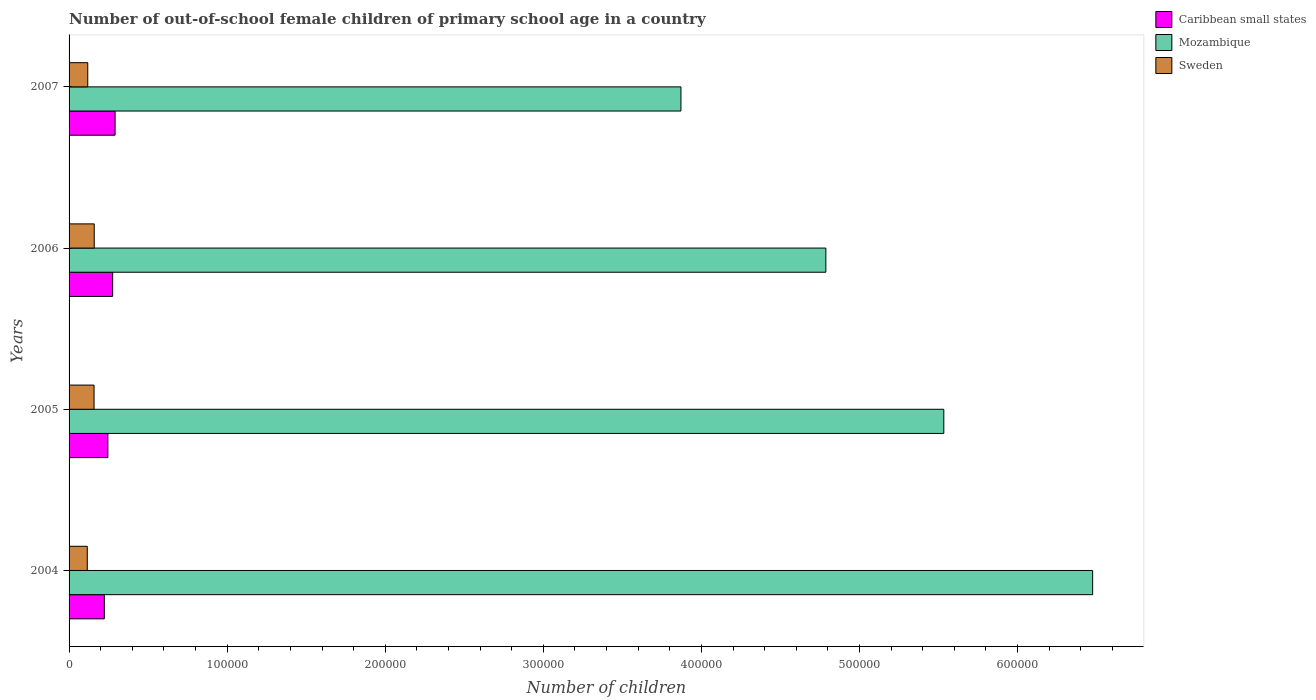How many different coloured bars are there?
Provide a succinct answer. 3. Are the number of bars per tick equal to the number of legend labels?
Make the answer very short. Yes. How many bars are there on the 3rd tick from the bottom?
Keep it short and to the point. 3. What is the label of the 4th group of bars from the top?
Ensure brevity in your answer.  2004. What is the number of out-of-school female children in Caribbean small states in 2007?
Your answer should be compact. 2.91e+04. Across all years, what is the maximum number of out-of-school female children in Mozambique?
Provide a succinct answer. 6.48e+05. Across all years, what is the minimum number of out-of-school female children in Mozambique?
Your response must be concise. 3.87e+05. In which year was the number of out-of-school female children in Sweden minimum?
Offer a very short reply. 2004. What is the total number of out-of-school female children in Sweden in the graph?
Provide a succinct answer. 5.51e+04. What is the difference between the number of out-of-school female children in Caribbean small states in 2004 and that in 2007?
Give a very brief answer. -6797. What is the difference between the number of out-of-school female children in Sweden in 2006 and the number of out-of-school female children in Caribbean small states in 2007?
Offer a terse response. -1.32e+04. What is the average number of out-of-school female children in Caribbean small states per year?
Provide a succinct answer. 2.59e+04. In the year 2007, what is the difference between the number of out-of-school female children in Mozambique and number of out-of-school female children in Sweden?
Offer a terse response. 3.75e+05. In how many years, is the number of out-of-school female children in Mozambique greater than 520000 ?
Ensure brevity in your answer.  2. What is the ratio of the number of out-of-school female children in Mozambique in 2004 to that in 2005?
Provide a short and direct response. 1.17. Is the number of out-of-school female children in Sweden in 2005 less than that in 2007?
Offer a terse response. No. What is the difference between the highest and the second highest number of out-of-school female children in Sweden?
Your answer should be compact. 113. What is the difference between the highest and the lowest number of out-of-school female children in Sweden?
Give a very brief answer. 4399. In how many years, is the number of out-of-school female children in Caribbean small states greater than the average number of out-of-school female children in Caribbean small states taken over all years?
Make the answer very short. 2. Is the sum of the number of out-of-school female children in Caribbean small states in 2004 and 2007 greater than the maximum number of out-of-school female children in Mozambique across all years?
Offer a terse response. No. What does the 3rd bar from the bottom in 2006 represents?
Provide a succinct answer. Sweden. Is it the case that in every year, the sum of the number of out-of-school female children in Mozambique and number of out-of-school female children in Caribbean small states is greater than the number of out-of-school female children in Sweden?
Make the answer very short. Yes. How many bars are there?
Keep it short and to the point. 12. Does the graph contain grids?
Your answer should be very brief. No. Where does the legend appear in the graph?
Give a very brief answer. Top right. How many legend labels are there?
Ensure brevity in your answer.  3. What is the title of the graph?
Make the answer very short. Number of out-of-school female children of primary school age in a country. What is the label or title of the X-axis?
Keep it short and to the point. Number of children. What is the label or title of the Y-axis?
Give a very brief answer. Years. What is the Number of children of Caribbean small states in 2004?
Provide a succinct answer. 2.23e+04. What is the Number of children in Mozambique in 2004?
Your answer should be compact. 6.48e+05. What is the Number of children in Sweden in 2004?
Offer a very short reply. 1.15e+04. What is the Number of children in Caribbean small states in 2005?
Keep it short and to the point. 2.46e+04. What is the Number of children in Mozambique in 2005?
Offer a very short reply. 5.53e+05. What is the Number of children in Sweden in 2005?
Offer a very short reply. 1.58e+04. What is the Number of children in Caribbean small states in 2006?
Provide a succinct answer. 2.76e+04. What is the Number of children in Mozambique in 2006?
Your answer should be compact. 4.79e+05. What is the Number of children of Sweden in 2006?
Make the answer very short. 1.59e+04. What is the Number of children in Caribbean small states in 2007?
Ensure brevity in your answer.  2.91e+04. What is the Number of children in Mozambique in 2007?
Your answer should be very brief. 3.87e+05. What is the Number of children of Sweden in 2007?
Provide a succinct answer. 1.18e+04. Across all years, what is the maximum Number of children in Caribbean small states?
Give a very brief answer. 2.91e+04. Across all years, what is the maximum Number of children in Mozambique?
Your response must be concise. 6.48e+05. Across all years, what is the maximum Number of children in Sweden?
Your answer should be very brief. 1.59e+04. Across all years, what is the minimum Number of children of Caribbean small states?
Make the answer very short. 2.23e+04. Across all years, what is the minimum Number of children in Mozambique?
Provide a succinct answer. 3.87e+05. Across all years, what is the minimum Number of children in Sweden?
Make the answer very short. 1.15e+04. What is the total Number of children of Caribbean small states in the graph?
Your answer should be compact. 1.04e+05. What is the total Number of children in Mozambique in the graph?
Provide a short and direct response. 2.07e+06. What is the total Number of children of Sweden in the graph?
Make the answer very short. 5.51e+04. What is the difference between the Number of children in Caribbean small states in 2004 and that in 2005?
Ensure brevity in your answer.  -2240. What is the difference between the Number of children of Mozambique in 2004 and that in 2005?
Offer a very short reply. 9.42e+04. What is the difference between the Number of children in Sweden in 2004 and that in 2005?
Offer a terse response. -4286. What is the difference between the Number of children of Caribbean small states in 2004 and that in 2006?
Your response must be concise. -5264. What is the difference between the Number of children in Mozambique in 2004 and that in 2006?
Provide a succinct answer. 1.69e+05. What is the difference between the Number of children of Sweden in 2004 and that in 2006?
Give a very brief answer. -4399. What is the difference between the Number of children in Caribbean small states in 2004 and that in 2007?
Provide a short and direct response. -6797. What is the difference between the Number of children in Mozambique in 2004 and that in 2007?
Provide a short and direct response. 2.60e+05. What is the difference between the Number of children of Sweden in 2004 and that in 2007?
Ensure brevity in your answer.  -294. What is the difference between the Number of children in Caribbean small states in 2005 and that in 2006?
Your response must be concise. -3024. What is the difference between the Number of children of Mozambique in 2005 and that in 2006?
Provide a short and direct response. 7.46e+04. What is the difference between the Number of children of Sweden in 2005 and that in 2006?
Ensure brevity in your answer.  -113. What is the difference between the Number of children of Caribbean small states in 2005 and that in 2007?
Provide a short and direct response. -4557. What is the difference between the Number of children in Mozambique in 2005 and that in 2007?
Offer a very short reply. 1.66e+05. What is the difference between the Number of children in Sweden in 2005 and that in 2007?
Offer a very short reply. 3992. What is the difference between the Number of children of Caribbean small states in 2006 and that in 2007?
Provide a succinct answer. -1533. What is the difference between the Number of children in Mozambique in 2006 and that in 2007?
Your answer should be compact. 9.17e+04. What is the difference between the Number of children in Sweden in 2006 and that in 2007?
Provide a succinct answer. 4105. What is the difference between the Number of children in Caribbean small states in 2004 and the Number of children in Mozambique in 2005?
Ensure brevity in your answer.  -5.31e+05. What is the difference between the Number of children in Caribbean small states in 2004 and the Number of children in Sweden in 2005?
Give a very brief answer. 6503. What is the difference between the Number of children of Mozambique in 2004 and the Number of children of Sweden in 2005?
Provide a short and direct response. 6.32e+05. What is the difference between the Number of children of Caribbean small states in 2004 and the Number of children of Mozambique in 2006?
Your response must be concise. -4.56e+05. What is the difference between the Number of children of Caribbean small states in 2004 and the Number of children of Sweden in 2006?
Offer a very short reply. 6390. What is the difference between the Number of children in Mozambique in 2004 and the Number of children in Sweden in 2006?
Offer a terse response. 6.32e+05. What is the difference between the Number of children in Caribbean small states in 2004 and the Number of children in Mozambique in 2007?
Give a very brief answer. -3.65e+05. What is the difference between the Number of children in Caribbean small states in 2004 and the Number of children in Sweden in 2007?
Ensure brevity in your answer.  1.05e+04. What is the difference between the Number of children in Mozambique in 2004 and the Number of children in Sweden in 2007?
Make the answer very short. 6.36e+05. What is the difference between the Number of children of Caribbean small states in 2005 and the Number of children of Mozambique in 2006?
Give a very brief answer. -4.54e+05. What is the difference between the Number of children in Caribbean small states in 2005 and the Number of children in Sweden in 2006?
Offer a terse response. 8630. What is the difference between the Number of children in Mozambique in 2005 and the Number of children in Sweden in 2006?
Provide a succinct answer. 5.37e+05. What is the difference between the Number of children in Caribbean small states in 2005 and the Number of children in Mozambique in 2007?
Provide a succinct answer. -3.63e+05. What is the difference between the Number of children in Caribbean small states in 2005 and the Number of children in Sweden in 2007?
Make the answer very short. 1.27e+04. What is the difference between the Number of children of Mozambique in 2005 and the Number of children of Sweden in 2007?
Provide a short and direct response. 5.42e+05. What is the difference between the Number of children in Caribbean small states in 2006 and the Number of children in Mozambique in 2007?
Give a very brief answer. -3.59e+05. What is the difference between the Number of children of Caribbean small states in 2006 and the Number of children of Sweden in 2007?
Offer a very short reply. 1.58e+04. What is the difference between the Number of children in Mozambique in 2006 and the Number of children in Sweden in 2007?
Give a very brief answer. 4.67e+05. What is the average Number of children of Caribbean small states per year?
Give a very brief answer. 2.59e+04. What is the average Number of children of Mozambique per year?
Provide a succinct answer. 5.17e+05. What is the average Number of children of Sweden per year?
Make the answer very short. 1.38e+04. In the year 2004, what is the difference between the Number of children of Caribbean small states and Number of children of Mozambique?
Make the answer very short. -6.25e+05. In the year 2004, what is the difference between the Number of children in Caribbean small states and Number of children in Sweden?
Provide a short and direct response. 1.08e+04. In the year 2004, what is the difference between the Number of children of Mozambique and Number of children of Sweden?
Offer a very short reply. 6.36e+05. In the year 2005, what is the difference between the Number of children of Caribbean small states and Number of children of Mozambique?
Your answer should be very brief. -5.29e+05. In the year 2005, what is the difference between the Number of children in Caribbean small states and Number of children in Sweden?
Provide a succinct answer. 8743. In the year 2005, what is the difference between the Number of children of Mozambique and Number of children of Sweden?
Ensure brevity in your answer.  5.38e+05. In the year 2006, what is the difference between the Number of children in Caribbean small states and Number of children in Mozambique?
Give a very brief answer. -4.51e+05. In the year 2006, what is the difference between the Number of children in Caribbean small states and Number of children in Sweden?
Give a very brief answer. 1.17e+04. In the year 2006, what is the difference between the Number of children in Mozambique and Number of children in Sweden?
Your answer should be compact. 4.63e+05. In the year 2007, what is the difference between the Number of children of Caribbean small states and Number of children of Mozambique?
Offer a very short reply. -3.58e+05. In the year 2007, what is the difference between the Number of children of Caribbean small states and Number of children of Sweden?
Your response must be concise. 1.73e+04. In the year 2007, what is the difference between the Number of children of Mozambique and Number of children of Sweden?
Provide a succinct answer. 3.75e+05. What is the ratio of the Number of children in Caribbean small states in 2004 to that in 2005?
Offer a terse response. 0.91. What is the ratio of the Number of children in Mozambique in 2004 to that in 2005?
Make the answer very short. 1.17. What is the ratio of the Number of children of Sweden in 2004 to that in 2005?
Make the answer very short. 0.73. What is the ratio of the Number of children of Caribbean small states in 2004 to that in 2006?
Your response must be concise. 0.81. What is the ratio of the Number of children of Mozambique in 2004 to that in 2006?
Your answer should be very brief. 1.35. What is the ratio of the Number of children in Sweden in 2004 to that in 2006?
Offer a very short reply. 0.72. What is the ratio of the Number of children in Caribbean small states in 2004 to that in 2007?
Keep it short and to the point. 0.77. What is the ratio of the Number of children in Mozambique in 2004 to that in 2007?
Your response must be concise. 1.67. What is the ratio of the Number of children of Sweden in 2004 to that in 2007?
Offer a very short reply. 0.98. What is the ratio of the Number of children of Caribbean small states in 2005 to that in 2006?
Your response must be concise. 0.89. What is the ratio of the Number of children of Mozambique in 2005 to that in 2006?
Provide a succinct answer. 1.16. What is the ratio of the Number of children of Sweden in 2005 to that in 2006?
Your answer should be very brief. 0.99. What is the ratio of the Number of children in Caribbean small states in 2005 to that in 2007?
Give a very brief answer. 0.84. What is the ratio of the Number of children in Mozambique in 2005 to that in 2007?
Ensure brevity in your answer.  1.43. What is the ratio of the Number of children of Sweden in 2005 to that in 2007?
Offer a terse response. 1.34. What is the ratio of the Number of children of Caribbean small states in 2006 to that in 2007?
Provide a succinct answer. 0.95. What is the ratio of the Number of children of Mozambique in 2006 to that in 2007?
Your answer should be very brief. 1.24. What is the ratio of the Number of children of Sweden in 2006 to that in 2007?
Keep it short and to the point. 1.35. What is the difference between the highest and the second highest Number of children of Caribbean small states?
Keep it short and to the point. 1533. What is the difference between the highest and the second highest Number of children of Mozambique?
Your answer should be compact. 9.42e+04. What is the difference between the highest and the second highest Number of children of Sweden?
Your response must be concise. 113. What is the difference between the highest and the lowest Number of children of Caribbean small states?
Offer a very short reply. 6797. What is the difference between the highest and the lowest Number of children in Mozambique?
Keep it short and to the point. 2.60e+05. What is the difference between the highest and the lowest Number of children of Sweden?
Your response must be concise. 4399. 